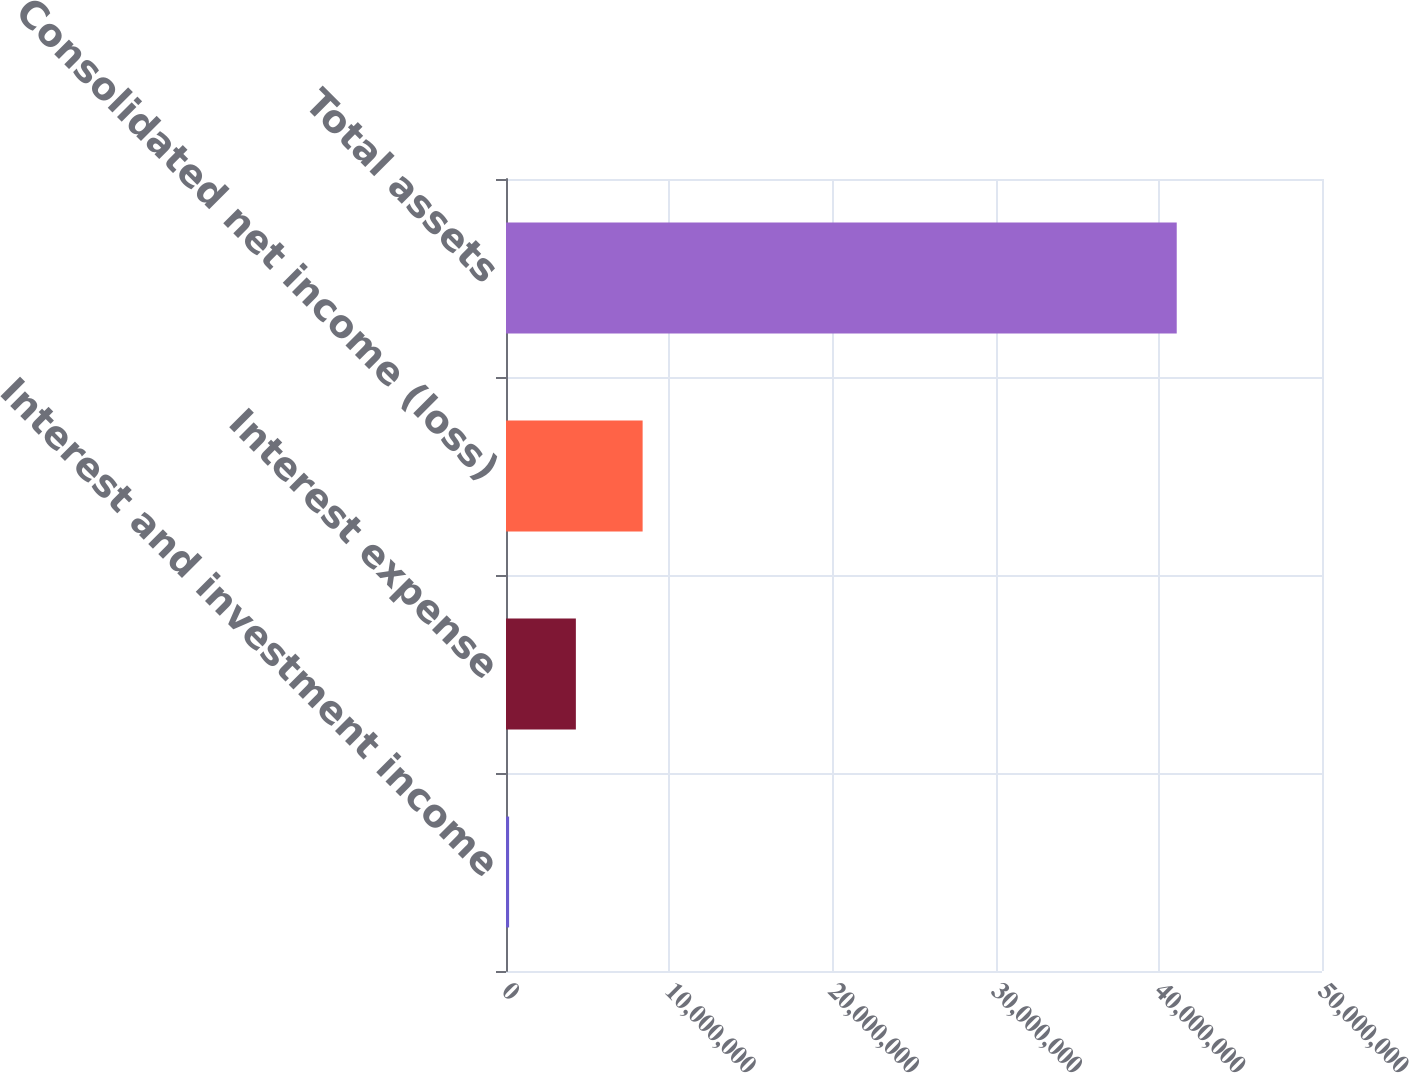Convert chart to OTSL. <chart><loc_0><loc_0><loc_500><loc_500><bar_chart><fcel>Interest and investment income<fcel>Interest expense<fcel>Consolidated net income (loss)<fcel>Total assets<nl><fcel>189994<fcel>4.28087e+06<fcel>8.37175e+06<fcel>4.10988e+07<nl></chart> 